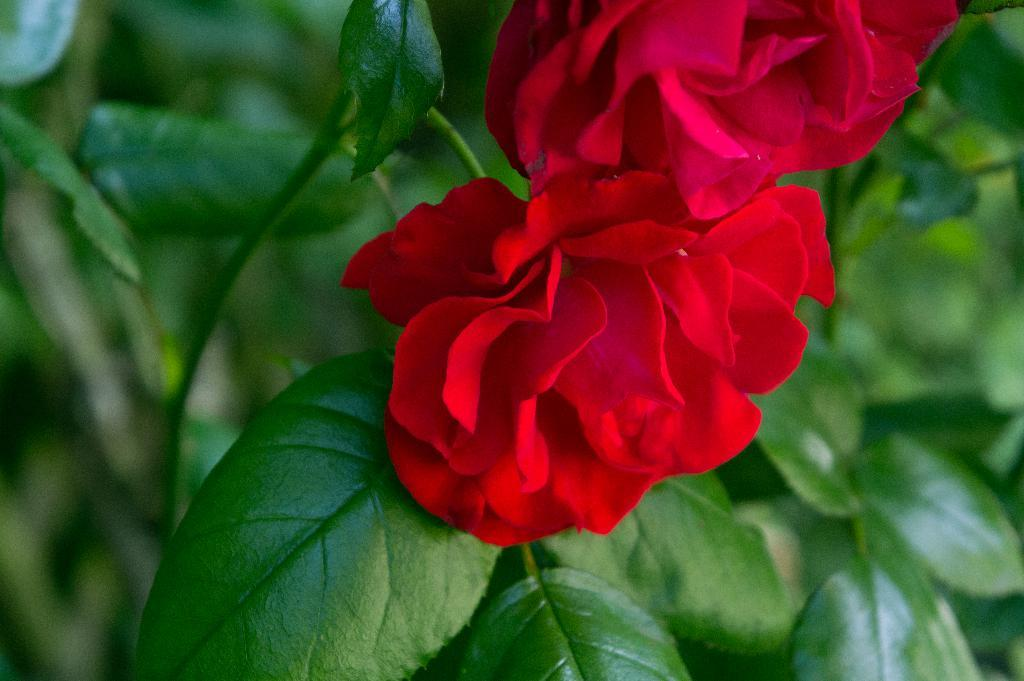What type of living organisms can be seen in the image? There are flowers and plants visible in the image. Can you describe the plants in the image? The plants in the image are not specified, but they are present alongside the flowers. What type of industry can be seen in the background of the image? There is no industry present in the image; it features flowers and plants. What type of art is displayed on the wall in the image? There is no art or wall present in the image; it features flowers and plants. 